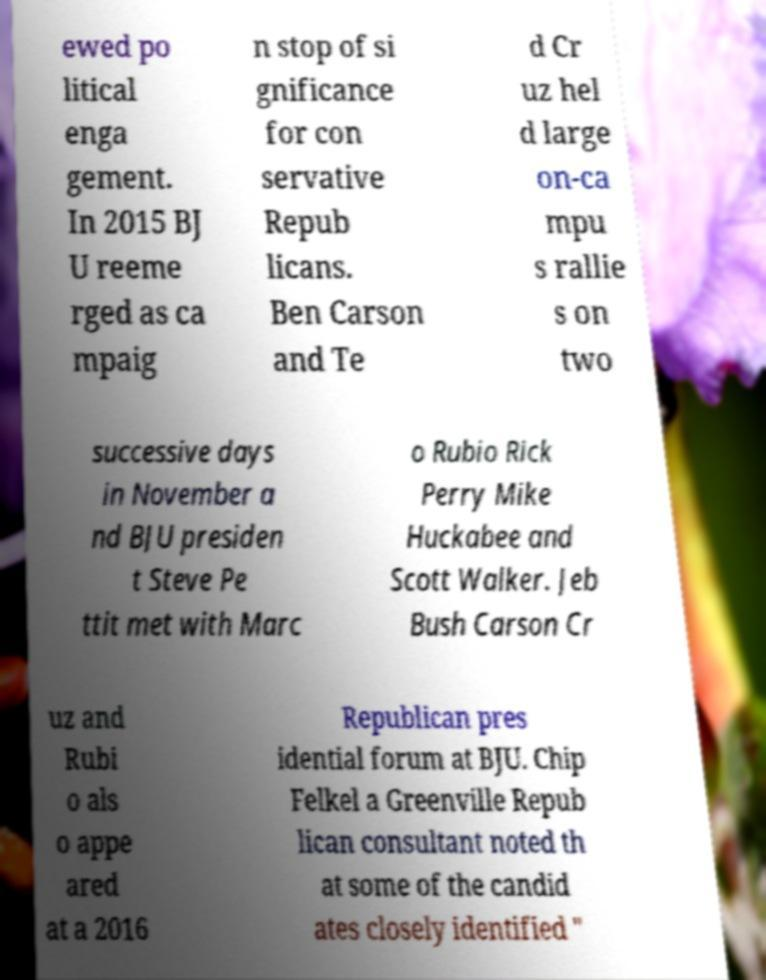Could you extract and type out the text from this image? ewed po litical enga gement. In 2015 BJ U reeme rged as ca mpaig n stop of si gnificance for con servative Repub licans. Ben Carson and Te d Cr uz hel d large on-ca mpu s rallie s on two successive days in November a nd BJU presiden t Steve Pe ttit met with Marc o Rubio Rick Perry Mike Huckabee and Scott Walker. Jeb Bush Carson Cr uz and Rubi o als o appe ared at a 2016 Republican pres idential forum at BJU. Chip Felkel a Greenville Repub lican consultant noted th at some of the candid ates closely identified " 